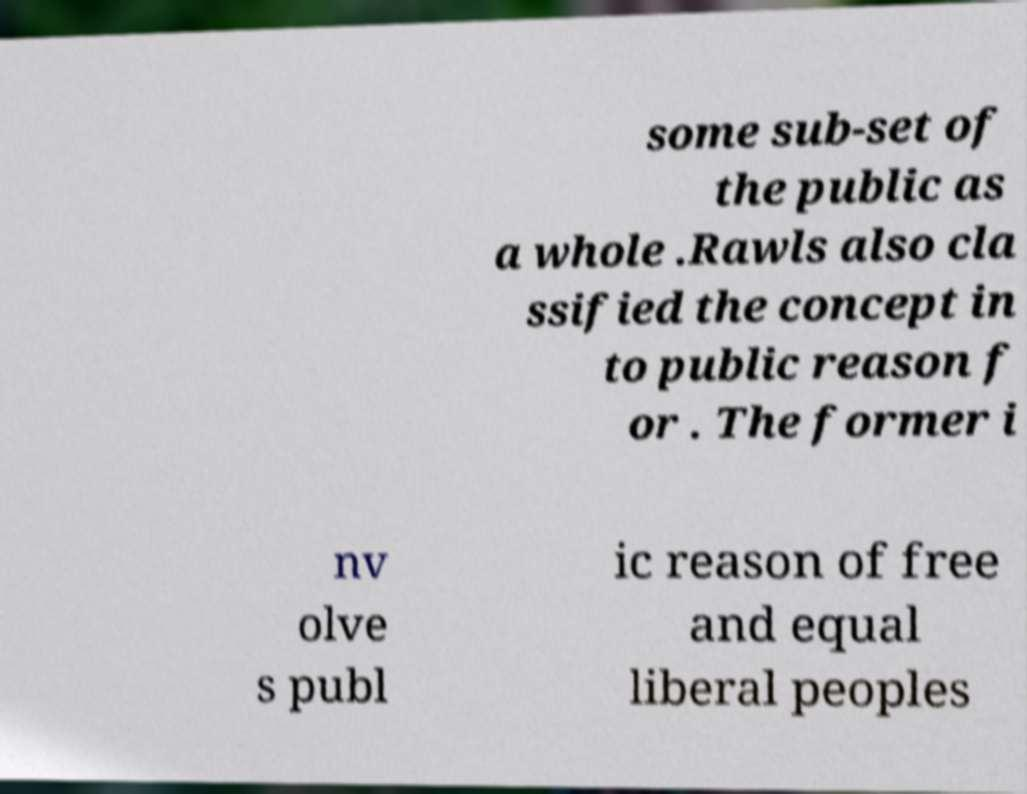Could you extract and type out the text from this image? some sub-set of the public as a whole .Rawls also cla ssified the concept in to public reason f or . The former i nv olve s publ ic reason of free and equal liberal peoples 